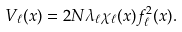Convert formula to latex. <formula><loc_0><loc_0><loc_500><loc_500>V _ { \ell } ( x ) = 2 N \lambda _ { \ell } \chi _ { \ell } ( x ) f ^ { 2 } _ { \ell } ( x ) .</formula> 